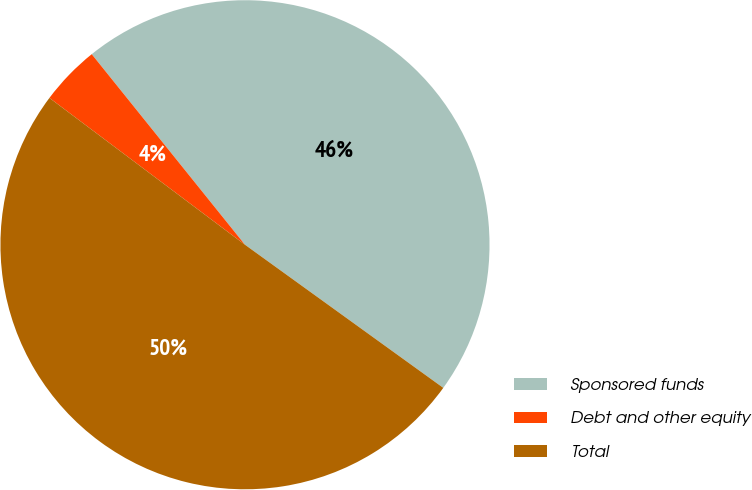Convert chart to OTSL. <chart><loc_0><loc_0><loc_500><loc_500><pie_chart><fcel>Sponsored funds<fcel>Debt and other equity<fcel>Total<nl><fcel>45.73%<fcel>3.97%<fcel>50.3%<nl></chart> 